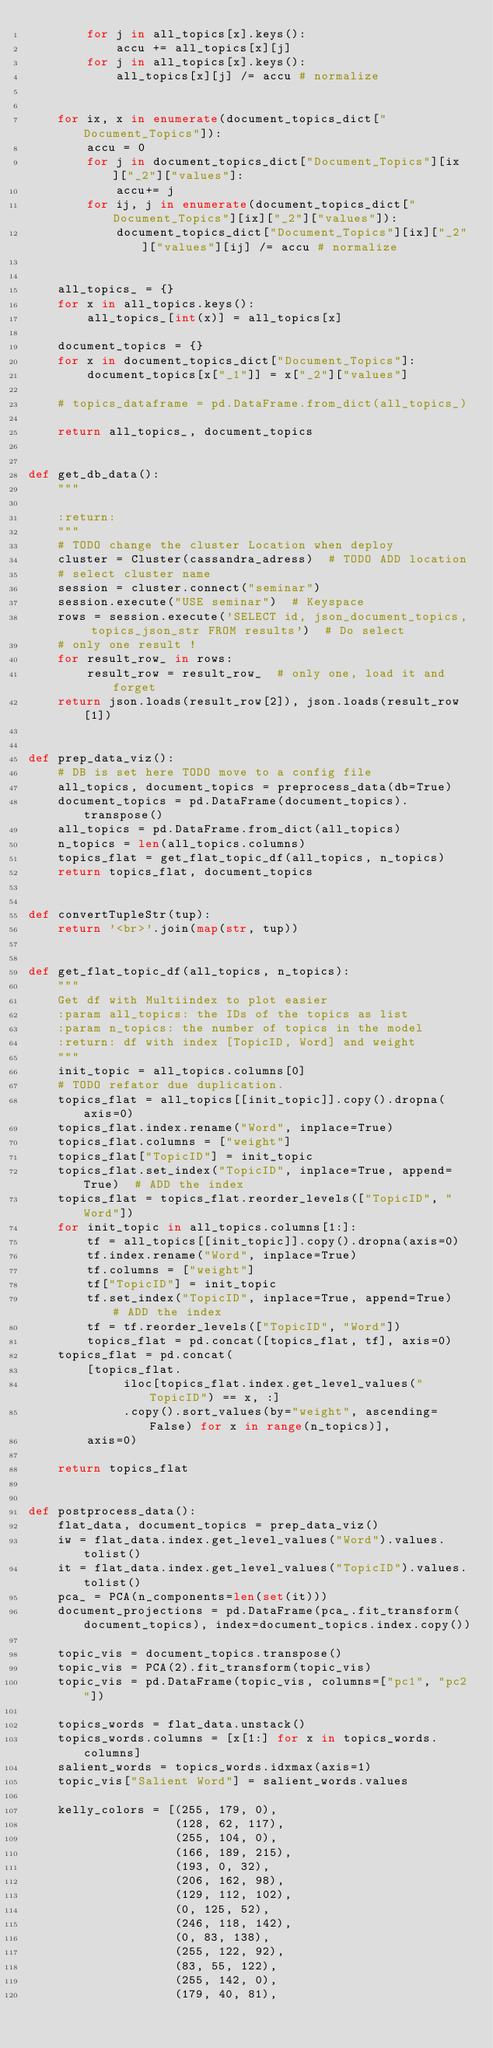Convert code to text. <code><loc_0><loc_0><loc_500><loc_500><_Python_>        for j in all_topics[x].keys():
            accu += all_topics[x][j]
        for j in all_topics[x].keys():
            all_topics[x][j] /= accu # normalize


    for ix, x in enumerate(document_topics_dict["Document_Topics"]):
        accu = 0
        for j in document_topics_dict["Document_Topics"][ix]["_2"]["values"]:
            accu+= j
        for ij, j in enumerate(document_topics_dict["Document_Topics"][ix]["_2"]["values"]):
            document_topics_dict["Document_Topics"][ix]["_2"]["values"][ij] /= accu # normalize


    all_topics_ = {}
    for x in all_topics.keys():
        all_topics_[int(x)] = all_topics[x]

    document_topics = {}
    for x in document_topics_dict["Document_Topics"]:
        document_topics[x["_1"]] = x["_2"]["values"]

    # topics_dataframe = pd.DataFrame.from_dict(all_topics_)

    return all_topics_, document_topics


def get_db_data():
    """

    :return:
    """
    # TODO change the cluster Location when deploy
    cluster = Cluster(cassandra_adress)  # TODO ADD location
    # select cluster name
    session = cluster.connect("seminar")
    session.execute("USE seminar")  # Keyspace
    rows = session.execute('SELECT id, json_document_topics, topics_json_str FROM results')  # Do select
    # only one result !
    for result_row_ in rows:
        result_row = result_row_  # only one, load it and forget
    return json.loads(result_row[2]), json.loads(result_row[1])


def prep_data_viz():
    # DB is set here TODO move to a config file
    all_topics, document_topics = preprocess_data(db=True)
    document_topics = pd.DataFrame(document_topics).transpose()
    all_topics = pd.DataFrame.from_dict(all_topics)
    n_topics = len(all_topics.columns)
    topics_flat = get_flat_topic_df(all_topics, n_topics)
    return topics_flat, document_topics


def convertTupleStr(tup):
    return '<br>'.join(map(str, tup))


def get_flat_topic_df(all_topics, n_topics):
    """
    Get df with Multiindex to plot easier
    :param all_topics: the IDs of the topics as list
    :param n_topics: the number of topics in the model
    :return: df with index [TopicID, Word] and weight
    """
    init_topic = all_topics.columns[0]
    # TODO refator due duplication.
    topics_flat = all_topics[[init_topic]].copy().dropna(axis=0)
    topics_flat.index.rename("Word", inplace=True)
    topics_flat.columns = ["weight"]
    topics_flat["TopicID"] = init_topic
    topics_flat.set_index("TopicID", inplace=True, append=True)  # ADD the index
    topics_flat = topics_flat.reorder_levels(["TopicID", "Word"])
    for init_topic in all_topics.columns[1:]:
        tf = all_topics[[init_topic]].copy().dropna(axis=0)
        tf.index.rename("Word", inplace=True)
        tf.columns = ["weight"]
        tf["TopicID"] = init_topic
        tf.set_index("TopicID", inplace=True, append=True)  # ADD the index
        tf = tf.reorder_levels(["TopicID", "Word"])
        topics_flat = pd.concat([topics_flat, tf], axis=0)
    topics_flat = pd.concat(
        [topics_flat.
             iloc[topics_flat.index.get_level_values("TopicID") == x, :]
             .copy().sort_values(by="weight", ascending=False) for x in range(n_topics)],
        axis=0)

    return topics_flat


def postprocess_data():
    flat_data, document_topics = prep_data_viz()
    iw = flat_data.index.get_level_values("Word").values.tolist()
    it = flat_data.index.get_level_values("TopicID").values.tolist()
    pca_ = PCA(n_components=len(set(it)))
    document_projections = pd.DataFrame(pca_.fit_transform(document_topics), index=document_topics.index.copy())

    topic_vis = document_topics.transpose()
    topic_vis = PCA(2).fit_transform(topic_vis)
    topic_vis = pd.DataFrame(topic_vis, columns=["pc1", "pc2"])

    topics_words = flat_data.unstack()
    topics_words.columns = [x[1:] for x in topics_words.columns]
    salient_words = topics_words.idxmax(axis=1)
    topic_vis["Salient Word"] = salient_words.values

    kelly_colors = [(255, 179, 0),
                    (128, 62, 117),
                    (255, 104, 0),
                    (166, 189, 215),
                    (193, 0, 32),
                    (206, 162, 98),
                    (129, 112, 102),
                    (0, 125, 52),
                    (246, 118, 142),
                    (0, 83, 138),
                    (255, 122, 92),
                    (83, 55, 122),
                    (255, 142, 0),
                    (179, 40, 81),</code> 